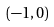<formula> <loc_0><loc_0><loc_500><loc_500>( - 1 , 0 )</formula> 